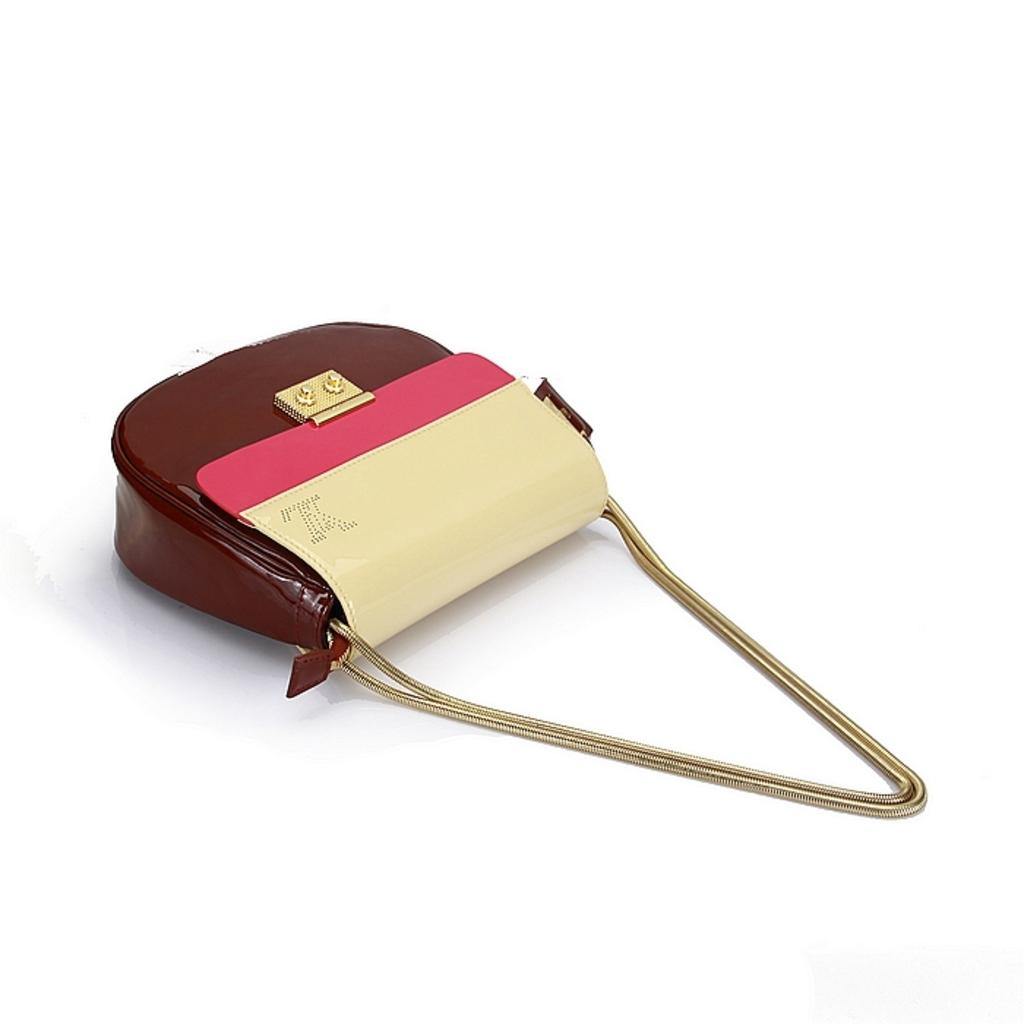What is the main subject of the image? The main focus of the image is a handbag. Can you describe the colors of the handbag? The handbag has brown, pink, and cream colors. What type of strap does the handbag have? The handbag has a chain strap. What type of cup is being used to hold the handbag in the image? There is no cup present in the image, and the handbag is not being held by any object. 